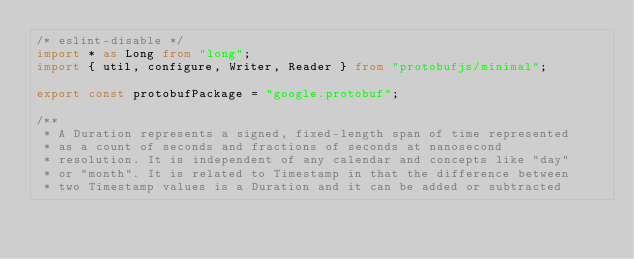Convert code to text. <code><loc_0><loc_0><loc_500><loc_500><_TypeScript_>/* eslint-disable */
import * as Long from "long";
import { util, configure, Writer, Reader } from "protobufjs/minimal";

export const protobufPackage = "google.protobuf";

/**
 * A Duration represents a signed, fixed-length span of time represented
 * as a count of seconds and fractions of seconds at nanosecond
 * resolution. It is independent of any calendar and concepts like "day"
 * or "month". It is related to Timestamp in that the difference between
 * two Timestamp values is a Duration and it can be added or subtracted</code> 